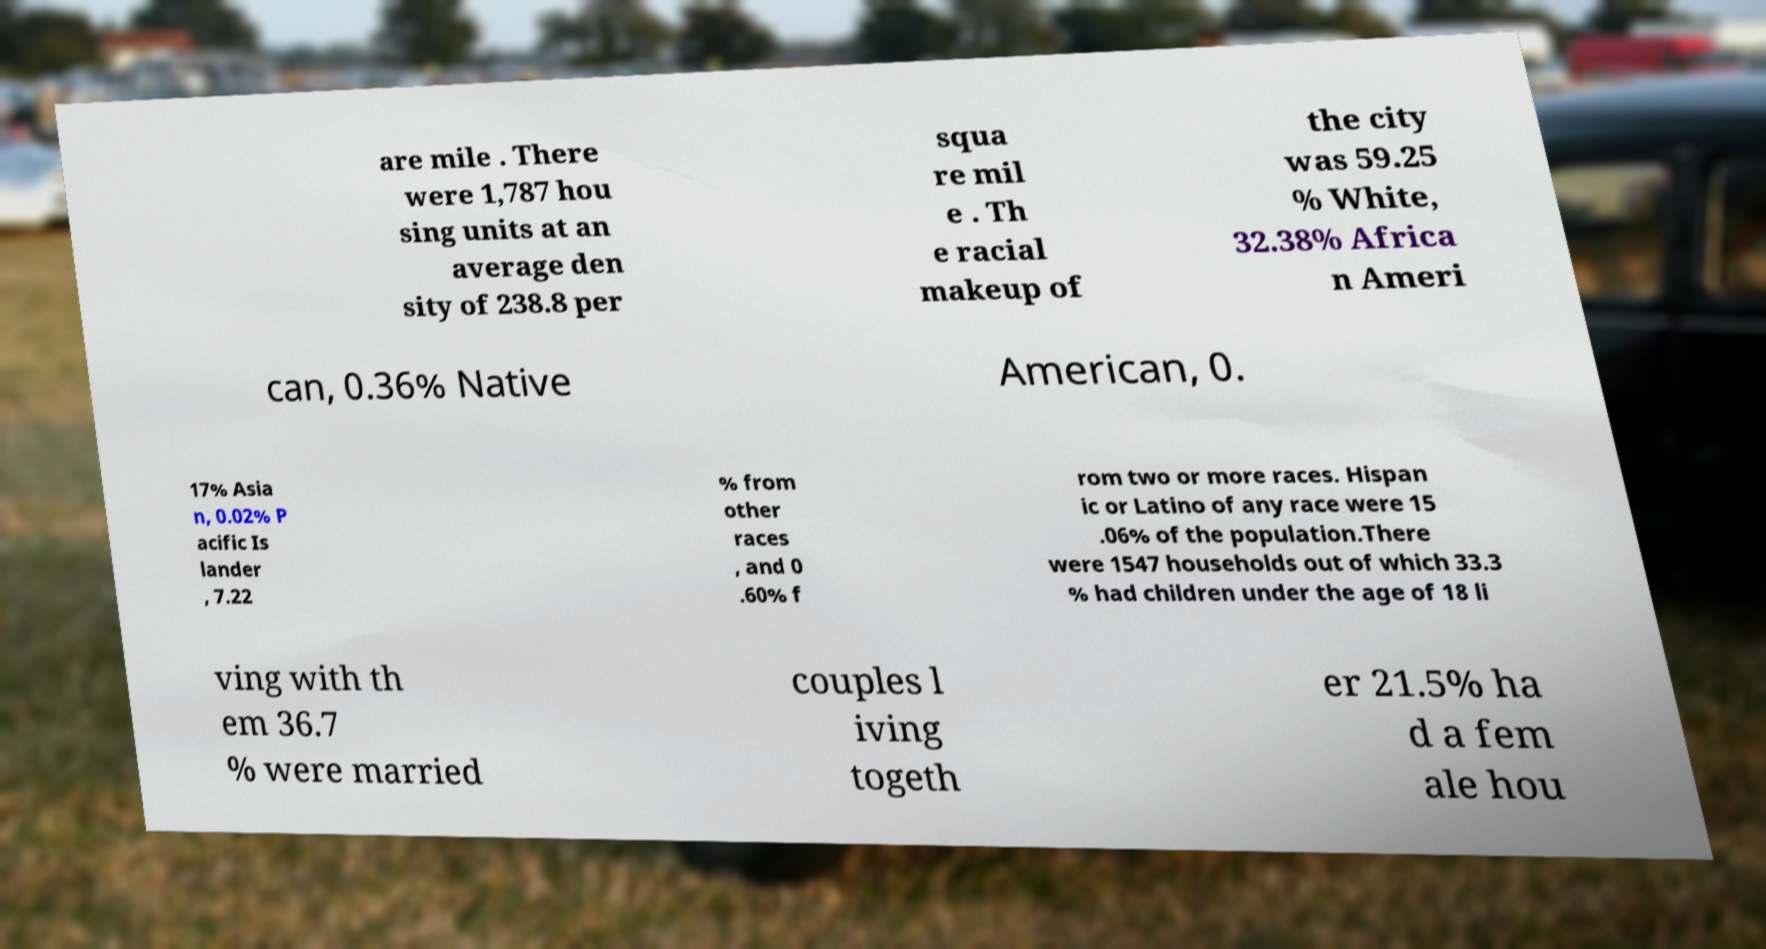Can you read and provide the text displayed in the image?This photo seems to have some interesting text. Can you extract and type it out for me? are mile . There were 1,787 hou sing units at an average den sity of 238.8 per squa re mil e . Th e racial makeup of the city was 59.25 % White, 32.38% Africa n Ameri can, 0.36% Native American, 0. 17% Asia n, 0.02% P acific Is lander , 7.22 % from other races , and 0 .60% f rom two or more races. Hispan ic or Latino of any race were 15 .06% of the population.There were 1547 households out of which 33.3 % had children under the age of 18 li ving with th em 36.7 % were married couples l iving togeth er 21.5% ha d a fem ale hou 